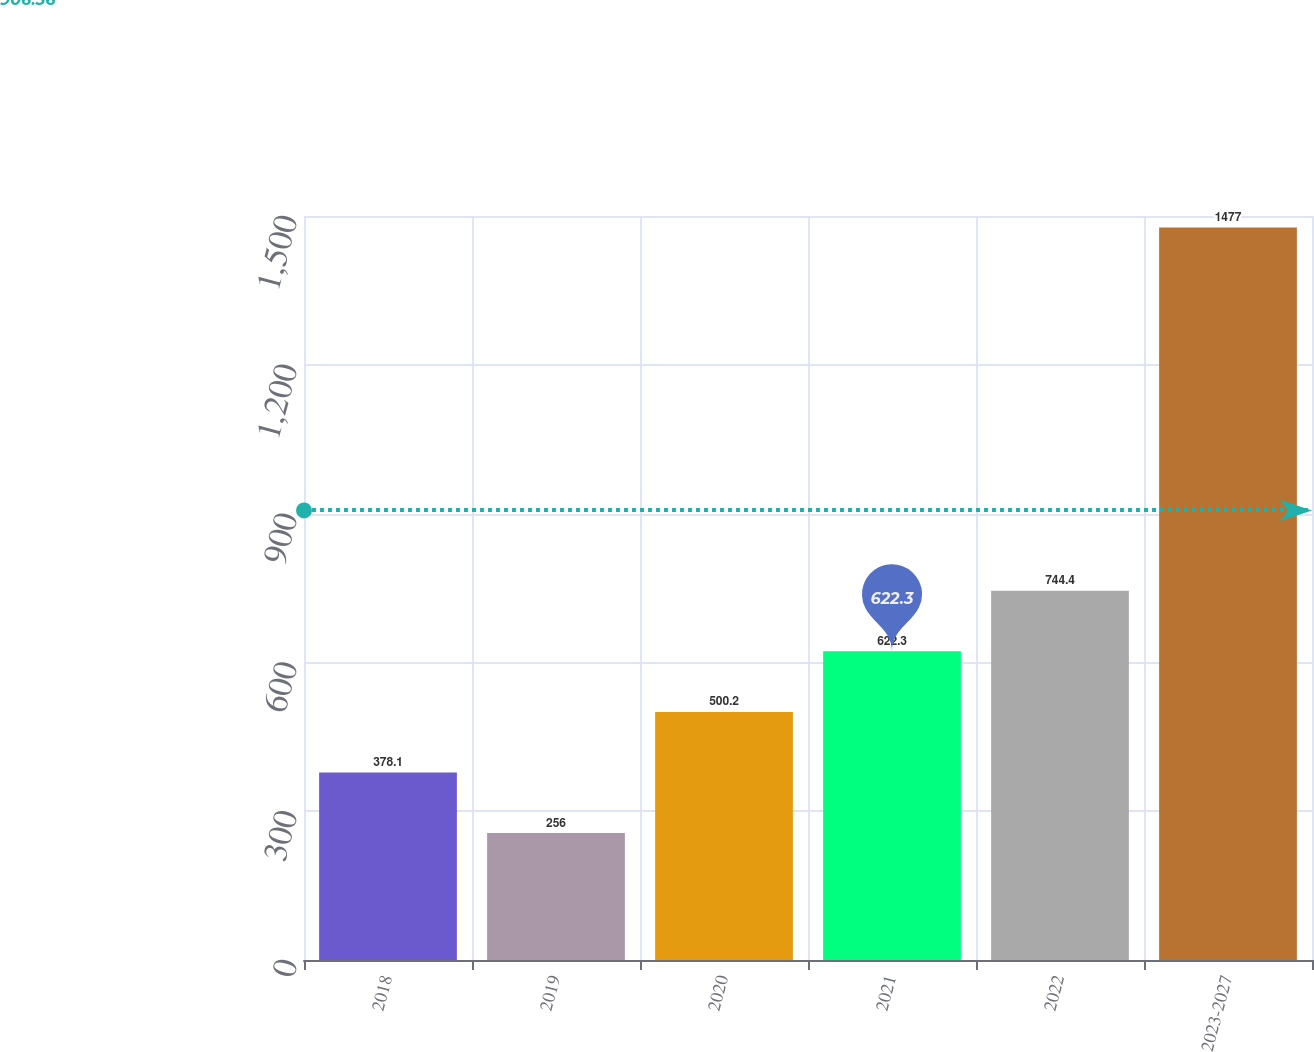<chart> <loc_0><loc_0><loc_500><loc_500><bar_chart><fcel>2018<fcel>2019<fcel>2020<fcel>2021<fcel>2022<fcel>2023-2027<nl><fcel>378.1<fcel>256<fcel>500.2<fcel>622.3<fcel>744.4<fcel>1477<nl></chart> 